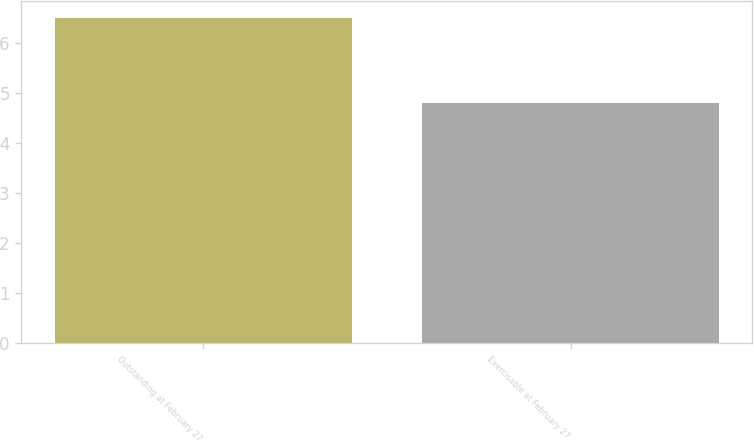<chart> <loc_0><loc_0><loc_500><loc_500><bar_chart><fcel>Outstanding at February 27<fcel>Exercisable at February 27<nl><fcel>6.5<fcel>4.8<nl></chart> 